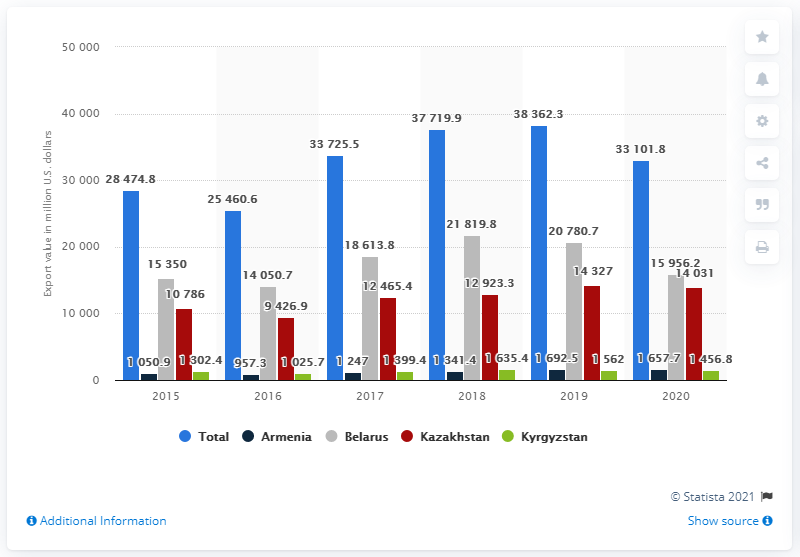List a handful of essential elements in this visual. In 2020, the value of Russian exports to the EAEU in dollars was 33,101.8 million. The highest value of goods was exported to Belarus. 